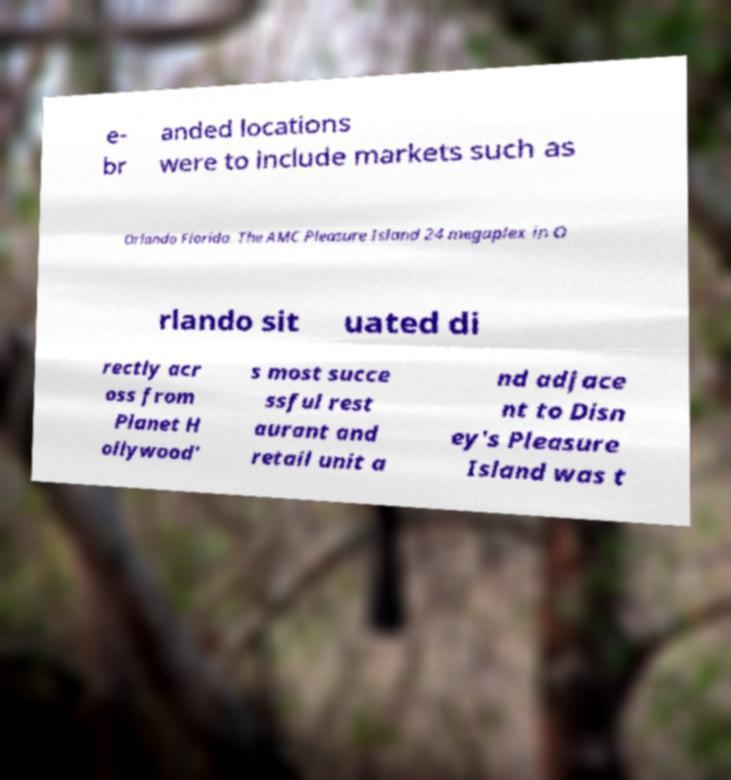Please read and relay the text visible in this image. What does it say? e- br anded locations were to include markets such as Orlando Florida. The AMC Pleasure Island 24 megaplex in O rlando sit uated di rectly acr oss from Planet H ollywood' s most succe ssful rest aurant and retail unit a nd adjace nt to Disn ey's Pleasure Island was t 